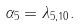<formula> <loc_0><loc_0><loc_500><loc_500>\alpha _ { 5 } = \lambda _ { 5 , 1 0 } .</formula> 